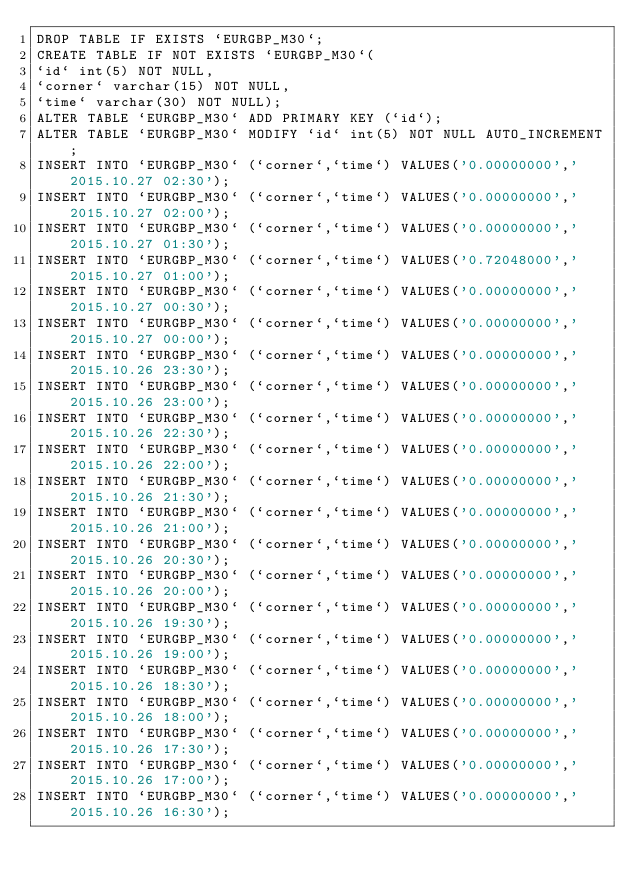Convert code to text. <code><loc_0><loc_0><loc_500><loc_500><_SQL_>DROP TABLE IF EXISTS `EURGBP_M30`;
CREATE TABLE IF NOT EXISTS `EURGBP_M30`(
`id` int(5) NOT NULL,
`corner` varchar(15) NOT NULL,
`time` varchar(30) NOT NULL);
ALTER TABLE `EURGBP_M30` ADD PRIMARY KEY (`id`);
ALTER TABLE `EURGBP_M30` MODIFY `id` int(5) NOT NULL AUTO_INCREMENT;
INSERT INTO `EURGBP_M30` (`corner`,`time`) VALUES('0.00000000','2015.10.27 02:30');
INSERT INTO `EURGBP_M30` (`corner`,`time`) VALUES('0.00000000','2015.10.27 02:00');
INSERT INTO `EURGBP_M30` (`corner`,`time`) VALUES('0.00000000','2015.10.27 01:30');
INSERT INTO `EURGBP_M30` (`corner`,`time`) VALUES('0.72048000','2015.10.27 01:00');
INSERT INTO `EURGBP_M30` (`corner`,`time`) VALUES('0.00000000','2015.10.27 00:30');
INSERT INTO `EURGBP_M30` (`corner`,`time`) VALUES('0.00000000','2015.10.27 00:00');
INSERT INTO `EURGBP_M30` (`corner`,`time`) VALUES('0.00000000','2015.10.26 23:30');
INSERT INTO `EURGBP_M30` (`corner`,`time`) VALUES('0.00000000','2015.10.26 23:00');
INSERT INTO `EURGBP_M30` (`corner`,`time`) VALUES('0.00000000','2015.10.26 22:30');
INSERT INTO `EURGBP_M30` (`corner`,`time`) VALUES('0.00000000','2015.10.26 22:00');
INSERT INTO `EURGBP_M30` (`corner`,`time`) VALUES('0.00000000','2015.10.26 21:30');
INSERT INTO `EURGBP_M30` (`corner`,`time`) VALUES('0.00000000','2015.10.26 21:00');
INSERT INTO `EURGBP_M30` (`corner`,`time`) VALUES('0.00000000','2015.10.26 20:30');
INSERT INTO `EURGBP_M30` (`corner`,`time`) VALUES('0.00000000','2015.10.26 20:00');
INSERT INTO `EURGBP_M30` (`corner`,`time`) VALUES('0.00000000','2015.10.26 19:30');
INSERT INTO `EURGBP_M30` (`corner`,`time`) VALUES('0.00000000','2015.10.26 19:00');
INSERT INTO `EURGBP_M30` (`corner`,`time`) VALUES('0.00000000','2015.10.26 18:30');
INSERT INTO `EURGBP_M30` (`corner`,`time`) VALUES('0.00000000','2015.10.26 18:00');
INSERT INTO `EURGBP_M30` (`corner`,`time`) VALUES('0.00000000','2015.10.26 17:30');
INSERT INTO `EURGBP_M30` (`corner`,`time`) VALUES('0.00000000','2015.10.26 17:00');
INSERT INTO `EURGBP_M30` (`corner`,`time`) VALUES('0.00000000','2015.10.26 16:30');</code> 